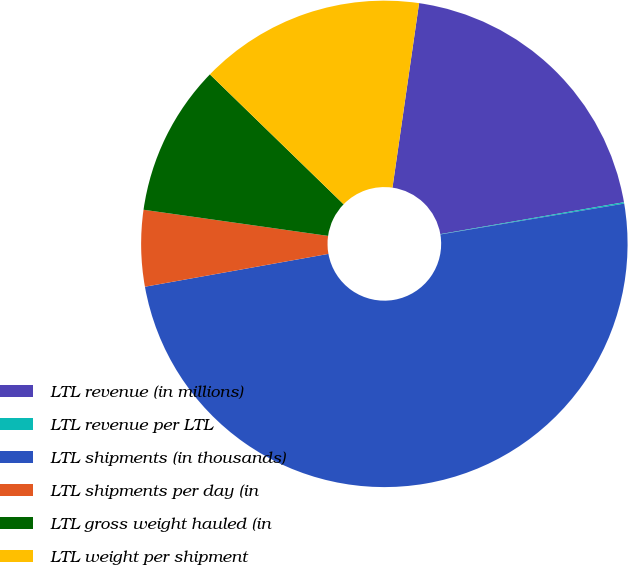Convert chart. <chart><loc_0><loc_0><loc_500><loc_500><pie_chart><fcel>LTL revenue (in millions)<fcel>LTL revenue per LTL<fcel>LTL shipments (in thousands)<fcel>LTL shipments per day (in<fcel>LTL gross weight hauled (in<fcel>LTL weight per shipment<nl><fcel>19.98%<fcel>0.09%<fcel>49.83%<fcel>5.06%<fcel>10.03%<fcel>15.01%<nl></chart> 